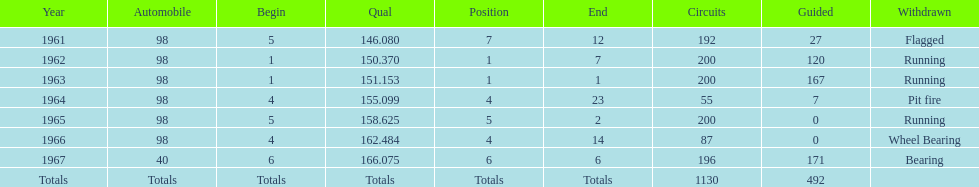Previous to 1965, when did jones have a number 5 start at the indy 500? 1961. 